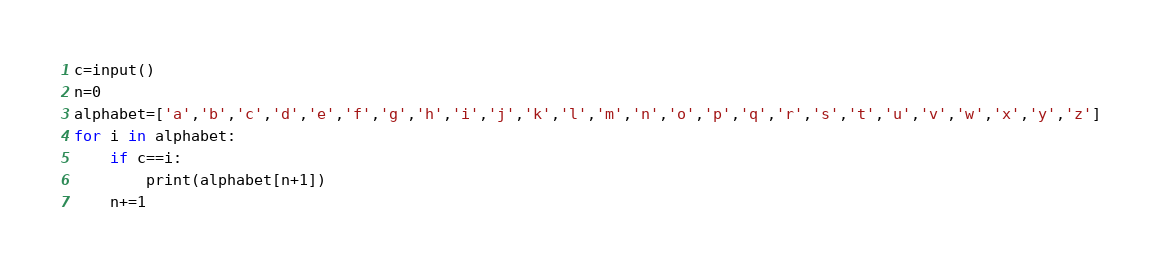Convert code to text. <code><loc_0><loc_0><loc_500><loc_500><_Python_>c=input()
n=0
alphabet=['a','b','c','d','e','f','g','h','i','j','k','l','m','n','o','p','q','r','s','t','u','v','w','x','y','z']
for i in alphabet:
    if c==i:
        print(alphabet[n+1])
    n+=1</code> 